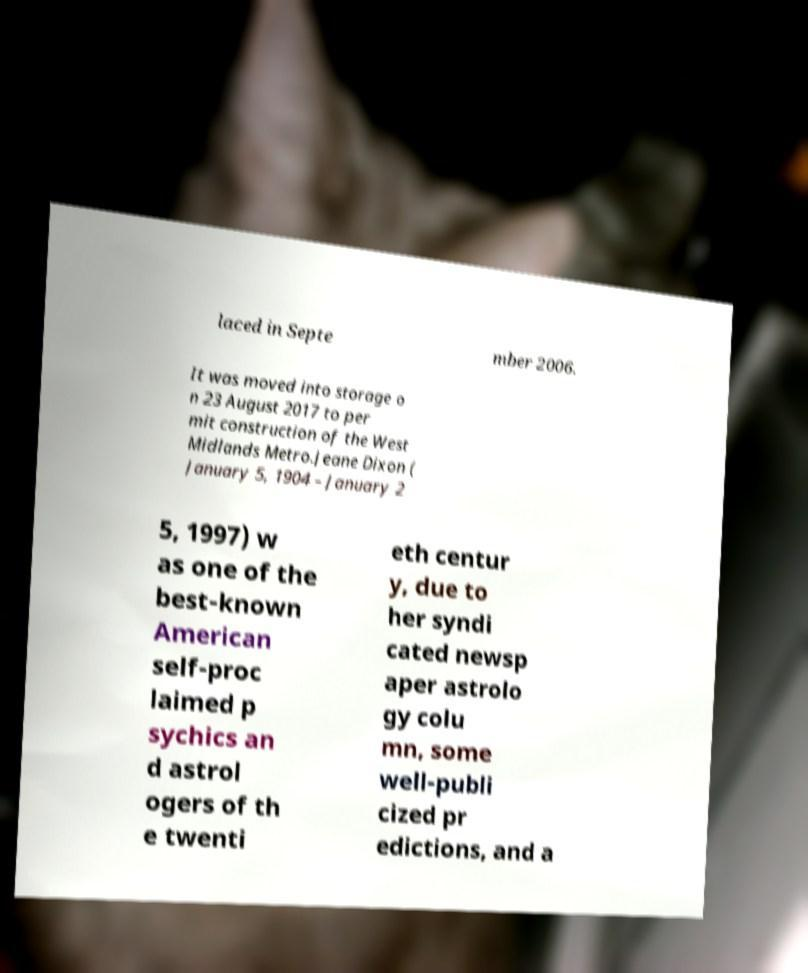For documentation purposes, I need the text within this image transcribed. Could you provide that? laced in Septe mber 2006. It was moved into storage o n 23 August 2017 to per mit construction of the West Midlands Metro.Jeane Dixon ( January 5, 1904 – January 2 5, 1997) w as one of the best-known American self-proc laimed p sychics an d astrol ogers of th e twenti eth centur y, due to her syndi cated newsp aper astrolo gy colu mn, some well-publi cized pr edictions, and a 